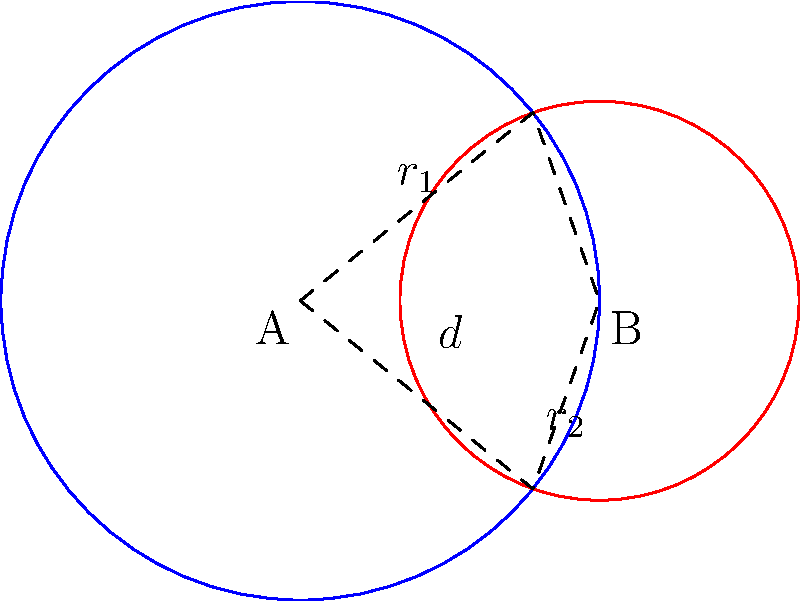In your garden, you have two circular flower beds that overlap. The larger bed, centered at point A, has a radius of 1.5 meters, while the smaller bed, centered at point B, has a radius of 1 meter. The centers of the two beds are 1.5 meters apart. What is the area of the overlapping region between these two flower beds? Let's approach this step-by-step:

1) First, we need to recall the formula for the area of overlap between two circles. It's given by:

   $$A = r_1^2 \arccos(\frac{d^2 + r_1^2 - r_2^2}{2dr_1}) + r_2^2 \arccos(\frac{d^2 + r_2^2 - r_1^2}{2dr_2}) - \frac{1}{2}\sqrt{(-d+r_1+r_2)(d+r_1-r_2)(d-r_1+r_2)(d+r_1+r_2)}$$

   Where $r_1$ and $r_2$ are the radii of the circles, and $d$ is the distance between their centers.

2) We're given:
   $r_1 = 1.5$ m (larger circle)
   $r_2 = 1$ m (smaller circle)
   $d = 1.5$ m (distance between centers)

3) Let's substitute these values into our formula:

   $$A = 1.5^2 \arccos(\frac{1.5^2 + 1.5^2 - 1^2}{2(1.5)(1.5)}) + 1^2 \arccos(\frac{1.5^2 + 1^2 - 1.5^2}{2(1.5)(1)}) - \frac{1}{2}\sqrt{(-1.5+1.5+1)(1.5+1.5-1)(1.5-1.5+1)(1.5+1.5+1)}$$

4) Simplify inside the arccos functions:
   
   $$A = 2.25 \arccos(\frac{4.5 - 1}{4.5}) + \arccos(\frac{3.25 - 2.25}{3}) - \frac{1}{2}\sqrt{(1)(2)(1)(4)}$$

5) Simplify further:

   $$A = 2.25 \arccos(\frac{7}{9}) + \arccos(\frac{1}{3}) - \sqrt{2}$$

6) Calculate (you may use a calculator for this step):

   $$A \approx 2.25 * 0.8571 + 1.2310 - 1.4142 \approx 1.7455$$

Therefore, the area of overlap is approximately 1.7455 square meters.
Answer: $1.7455$ m² 